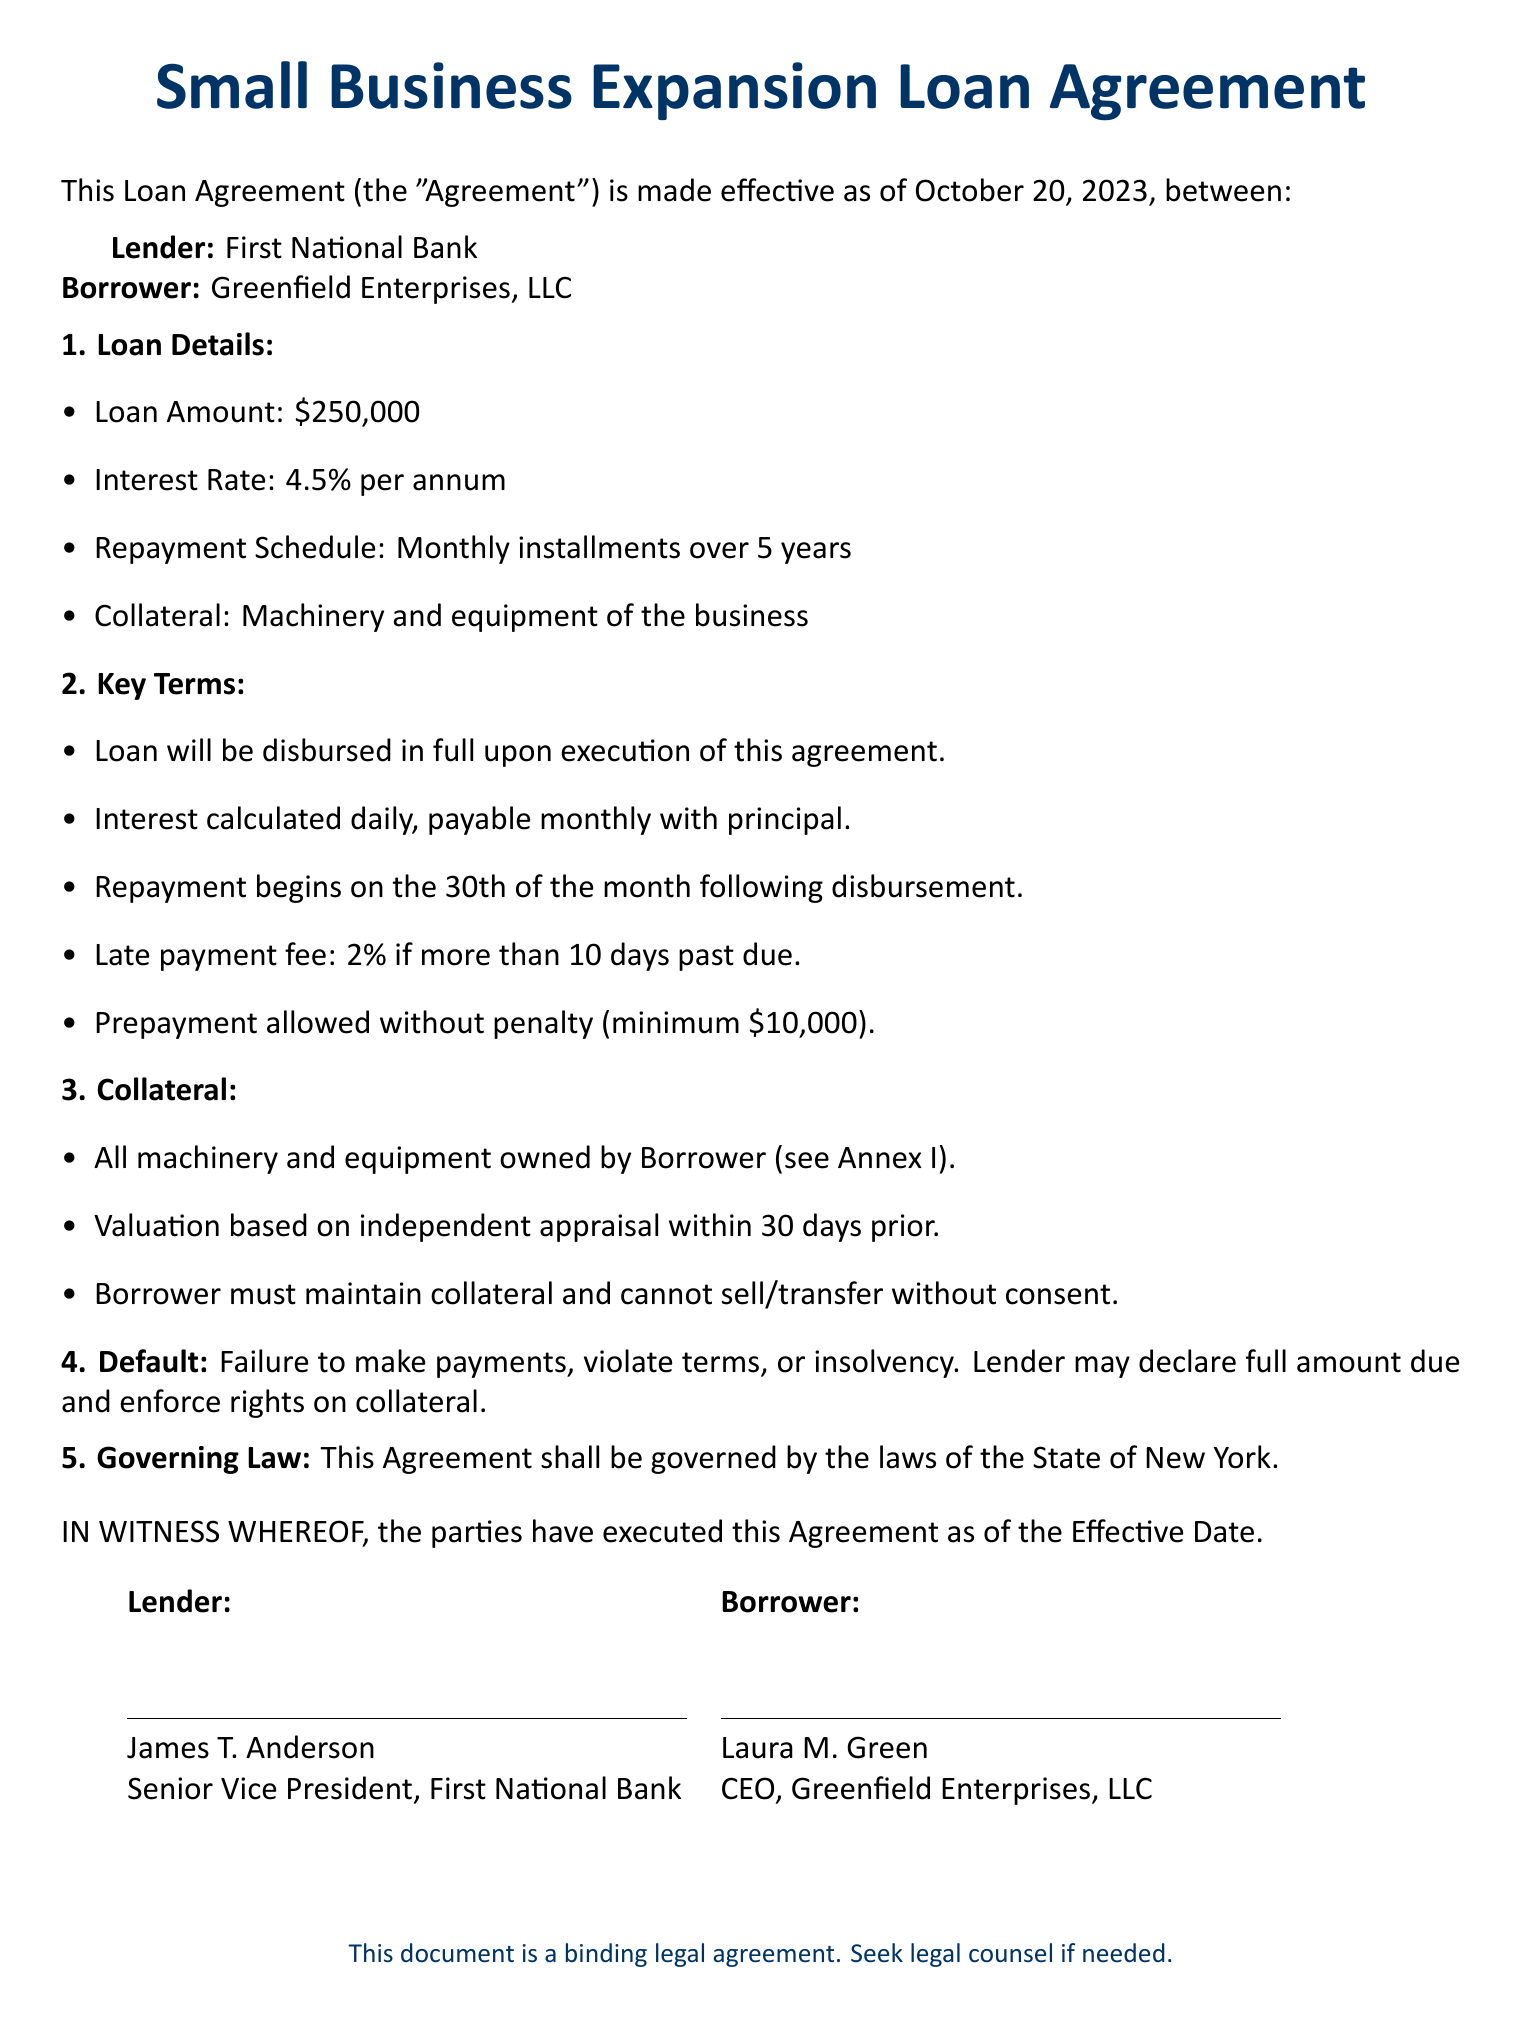What is the loan amount? The loan amount is specified in the document as the total amount being borrowed, which is $250,000.
Answer: $250,000 What is the interest rate for the loan? The interest rate is the percentage charged on the loan amount annually, which is stated as 4.5% per annum.
Answer: 4.5% What is the repayment schedule? The repayment schedule describes how repayments will be made over time, which in this case is monthly installments over 5 years.
Answer: Monthly installments over 5 years What type of collateral is required? The collateral refers to the assets pledged against the loan, which is specified as machinery and equipment of the business.
Answer: Machinery and equipment What happens in the case of default? The default section outlines the consequences if payments are not made or terms are violated, indicating that the lender may declare the full amount due and enforce rights on collateral.
Answer: Declare full amount due and enforce rights on collateral When does repayment begin? The repayment start date is outlined in the document, stating that it begins on the 30th of the month following disbursement.
Answer: 30th of the month following disbursement Is prepayment allowed? The key terms mention if there are provisions for prepayments and any penalties associated with it, which is specified as allowed without penalty (minimum $10,000).
Answer: Allowed without penalty (minimum $10,000) Who are the parties involved in this agreement? The document lists the participants involved, identifying the lender and the borrower as First National Bank and Greenfield Enterprises, LLC, respectively.
Answer: First National Bank and Greenfield Enterprises, LLC What is the effective date of the agreement? The effective date of the agreement indicates when it officially starts, as stated in the document, which is October 20, 2023.
Answer: October 20, 2023 